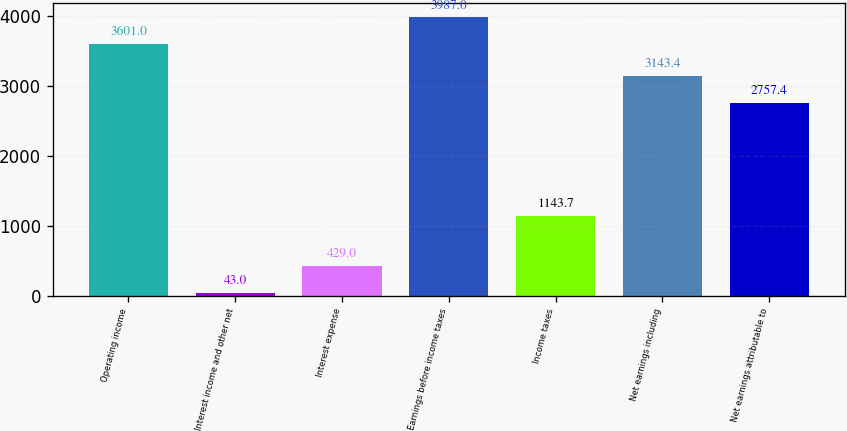Convert chart. <chart><loc_0><loc_0><loc_500><loc_500><bar_chart><fcel>Operating income<fcel>Interest income and other net<fcel>Interest expense<fcel>Earnings before income taxes<fcel>Income taxes<fcel>Net earnings including<fcel>Net earnings attributable to<nl><fcel>3601<fcel>43<fcel>429<fcel>3987<fcel>1143.7<fcel>3143.4<fcel>2757.4<nl></chart> 